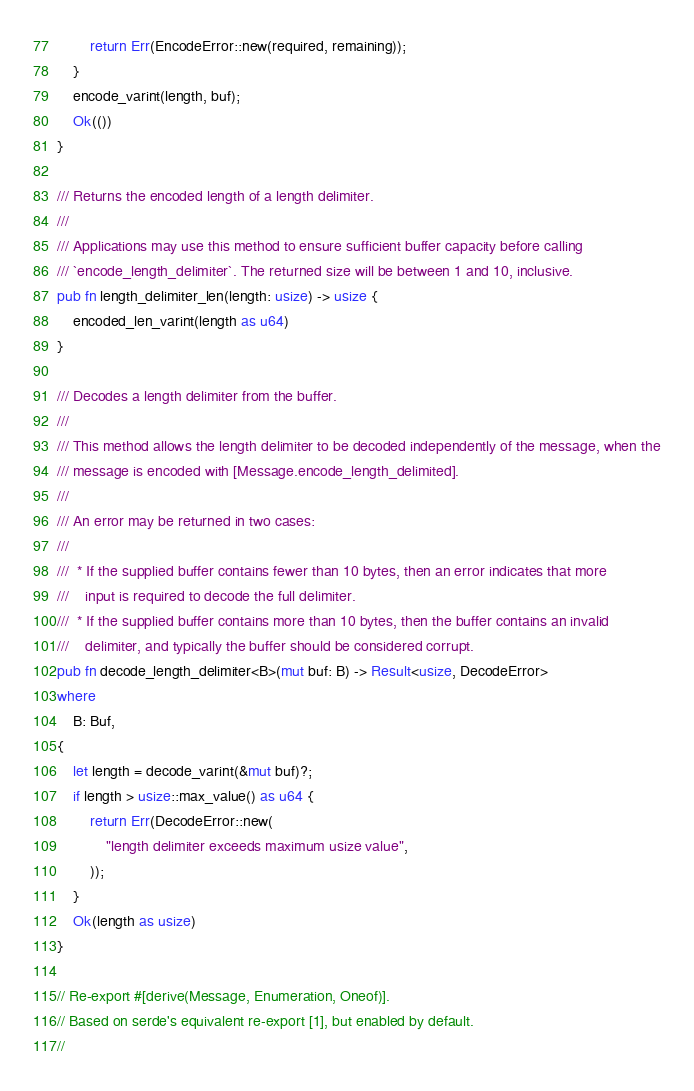<code> <loc_0><loc_0><loc_500><loc_500><_Rust_>        return Err(EncodeError::new(required, remaining));
    }
    encode_varint(length, buf);
    Ok(())
}

/// Returns the encoded length of a length delimiter.
///
/// Applications may use this method to ensure sufficient buffer capacity before calling
/// `encode_length_delimiter`. The returned size will be between 1 and 10, inclusive.
pub fn length_delimiter_len(length: usize) -> usize {
    encoded_len_varint(length as u64)
}

/// Decodes a length delimiter from the buffer.
///
/// This method allows the length delimiter to be decoded independently of the message, when the
/// message is encoded with [Message.encode_length_delimited].
///
/// An error may be returned in two cases:
///
///  * If the supplied buffer contains fewer than 10 bytes, then an error indicates that more
///    input is required to decode the full delimiter.
///  * If the supplied buffer contains more than 10 bytes, then the buffer contains an invalid
///    delimiter, and typically the buffer should be considered corrupt.
pub fn decode_length_delimiter<B>(mut buf: B) -> Result<usize, DecodeError>
where
    B: Buf,
{
    let length = decode_varint(&mut buf)?;
    if length > usize::max_value() as u64 {
        return Err(DecodeError::new(
            "length delimiter exceeds maximum usize value",
        ));
    }
    Ok(length as usize)
}

// Re-export #[derive(Message, Enumeration, Oneof)].
// Based on serde's equivalent re-export [1], but enabled by default.
//</code> 